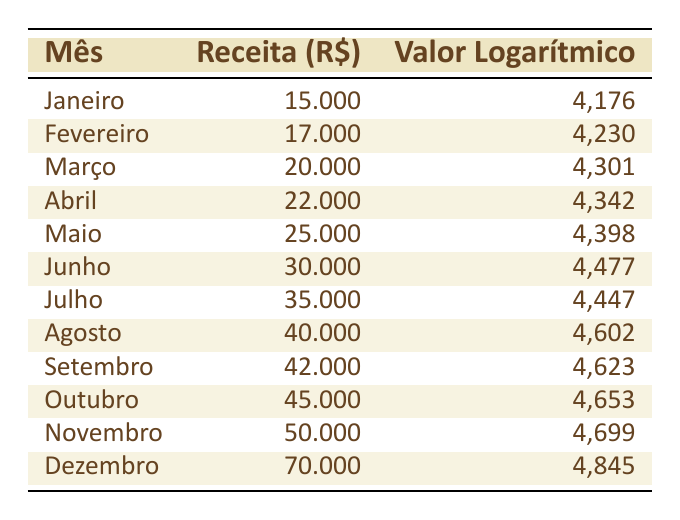Qual foi a receita do mês de dezembro? A tabela mostra que, em dezembro, a receita foi de R$ 70.000. Isso pode ser encontrado diretamente na coluna de receita da linha correspondente a dezembro.
Answer: 70.000 Qual foi a receita média dos meses de janeiro a junho? Para calcular a receita média de janeiro a junho, somamos as receitas desses meses: 15.000 + 17.000 + 20.000 + 22.000 + 25.000 + 30.000 = 129.000. Existem 6 meses, então a média é 129.000 / 6 = 21.500.
Answer: 21.500 Em qual mês a receita logarítmica foi maior? A tabela mostra que a receita logarítmica foi maior em dezembro, com um valor de 4,845. Esta informação pode ser obtida comparando os valores logarítmicos de cada mês.
Answer: Dezembro A receita total do ano foi superior a R$ 500.000? A soma das receitas de todos os meses é 15.000 + 17.000 + 20.000 + 22.000 + 25.000 + 30.000 + 35.000 + 40.000 + 42.000 + 45.000 + 50.000 + 70.000 =  400.000. Isto é inferior a 500.000, portanto, a afirmação é falsa.
Answer: Não Qual foi a diferença de receita entre novembro e janeiro? A receita de novembro foi de 50.000 e a de janeiro foi de 15.000. Para encontrar a diferença, subtraímos as duas: 50.000 - 15.000 = 35.000.
Answer: 35.000 Julho teve uma receita maior que a de junho? A tabela indica que a receita de julho foi de 35.000 e a de junho foi de 30.000. Comparando os dois valores, vemos que julho teve uma receita maior.
Answer: Sim Qual mês teve o maior aumento de receita em relação ao mês anterior? Para calcular os aumentos mensais, subtraímos a receita de cada mês da receita do mês anterior: Fevereiro (17.000 - 15.000 = 2.000), Março (20.000 - 17.000 = 3.000), Abril (22.000 - 20.000 = 2.000), etc. O maior aumento foi em março, com 3.000.
Answer: Março Qual foi a receita de agosto e como ela se compara à de outubro? A tabela mostra que a receita de agosto foi de 40.000 e a de outubro foi de 45.000. Comparando os dois valores, podemos ver que a receita de outubro foi maior que a de agosto.
Answer: Outubro foi maior Em quantos meses a receita foi superior a R$ 30.000? Observando a tabela, podemos contar os meses em que a receita ultrapassou 30.000: junho, julho, agosto, setembro, outubro, novembro e dezembro. Isso nos dá um total de 7 meses.
Answer: 7 meses 